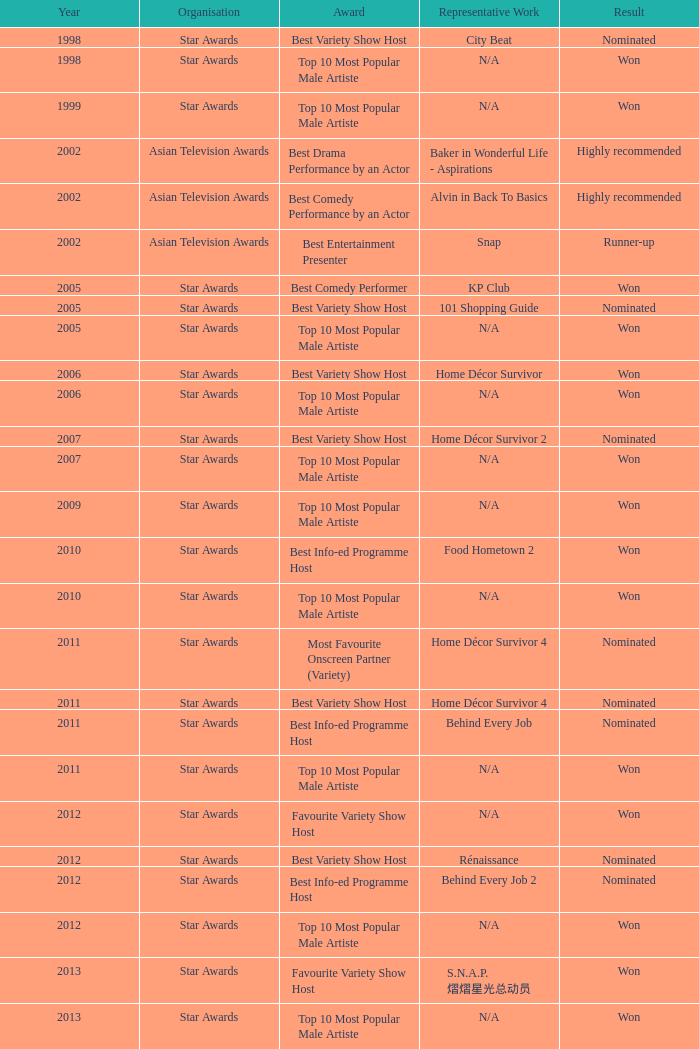Which award was presented to the winners of the star awards up until 2004? Top 10 Most Popular Male Artiste, Top 10 Most Popular Male Artiste. 